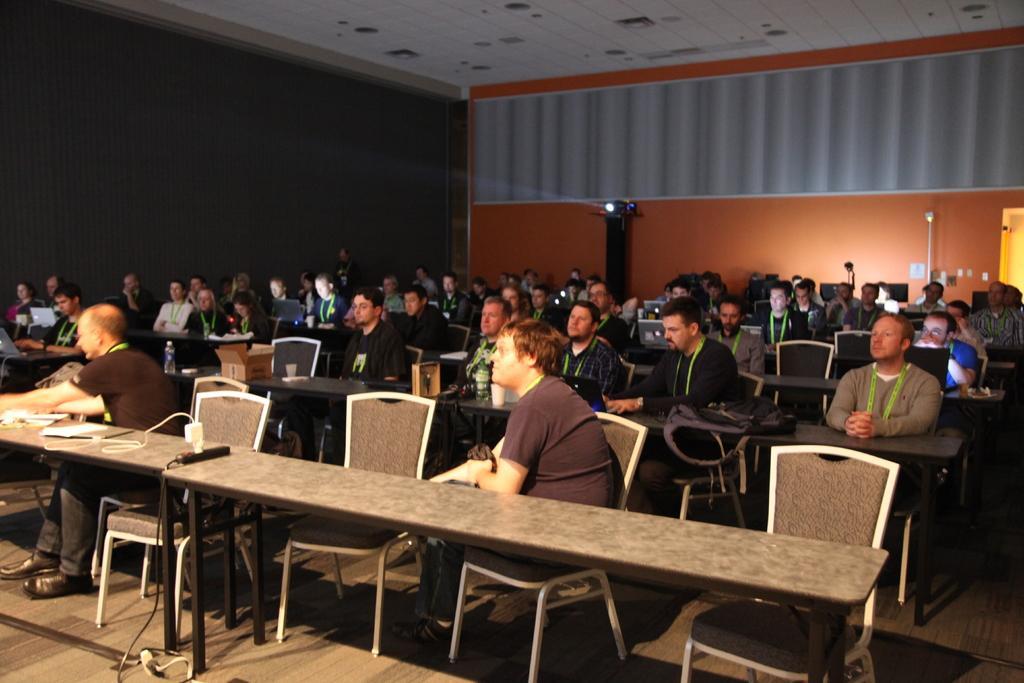Could you give a brief overview of what you see in this image? In this image we can see a group of people who are sitting on a chair and they are working on a laptop. Here we can see a projector. 